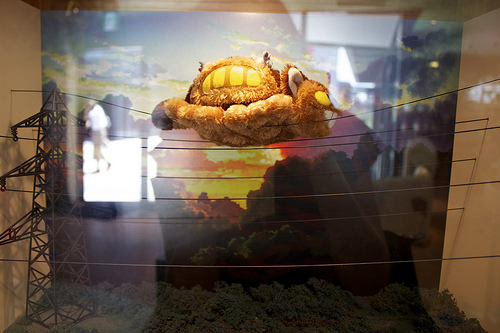<image>
Can you confirm if the stuffed animal is on the grass? No. The stuffed animal is not positioned on the grass. They may be near each other, but the stuffed animal is not supported by or resting on top of the grass. 